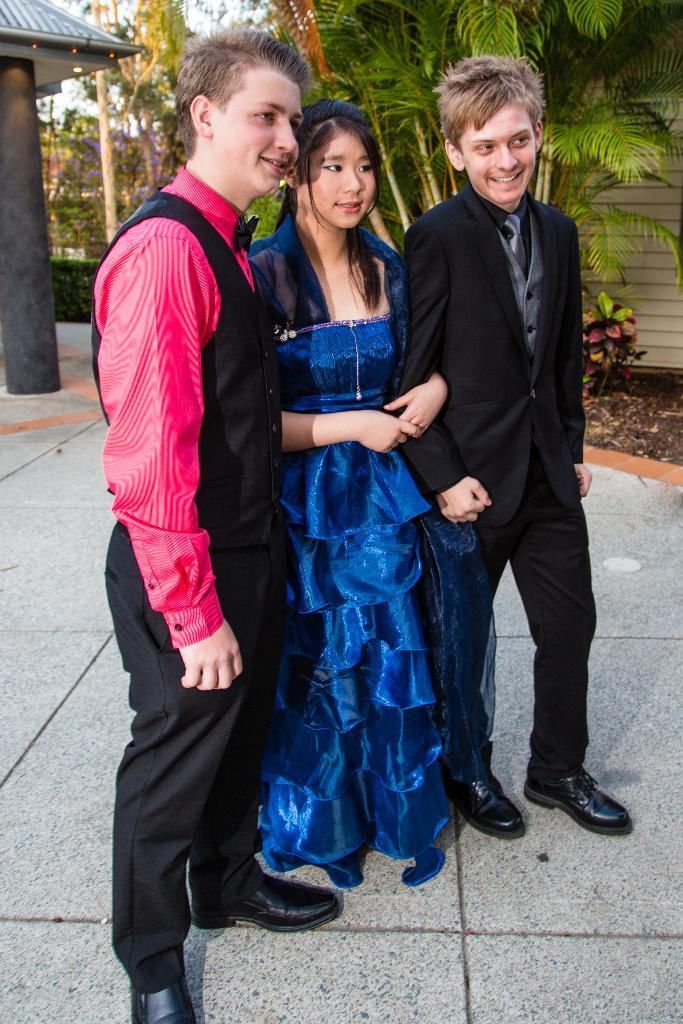How many children are in the image? There are two boys and a girl in the image. What are the children doing in the image? The children are standing and smiling. In which direction are the children looking? They are looking towards the right side. What can be seen in the background of the image? There are many plants and trees in the background. What is on the left side of the image? There is a pillar on the left side of the image. Can you see any frogs hopping on the slope in the image? There is no slope or frog present in the image. 